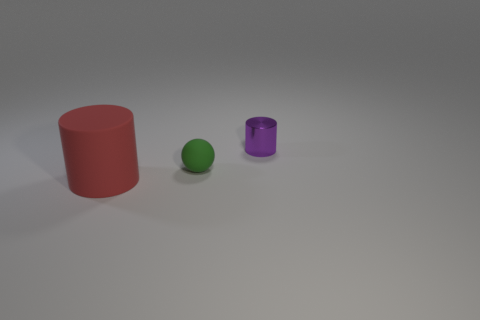There is a big red object; is it the same shape as the matte thing that is behind the red rubber thing?
Offer a very short reply. No. Are there fewer purple shiny objects in front of the red cylinder than rubber balls?
Offer a terse response. Yes. Is the small purple thing the same shape as the small green rubber object?
Offer a very short reply. No. What is the size of the red cylinder that is made of the same material as the green object?
Offer a terse response. Large. Are there fewer green matte things than small purple metallic balls?
Offer a very short reply. No. What number of big objects are red things or blue matte cylinders?
Make the answer very short. 1. What number of cylinders are on the left side of the green rubber thing and behind the big red cylinder?
Make the answer very short. 0. Are there more yellow things than green rubber balls?
Keep it short and to the point. No. What number of other objects are there of the same shape as the large red rubber thing?
Ensure brevity in your answer.  1. Is the small metal cylinder the same color as the large thing?
Ensure brevity in your answer.  No. 